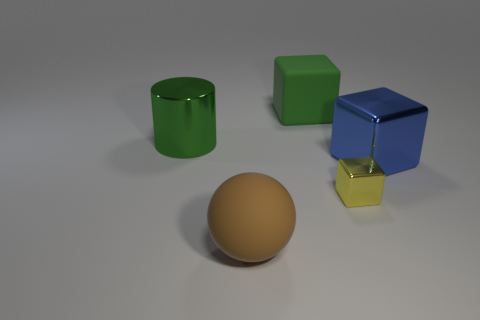Subtract all big blocks. How many blocks are left? 1 Subtract all yellow cubes. How many cubes are left? 2 Add 4 metallic cubes. How many objects exist? 9 Subtract 0 yellow cylinders. How many objects are left? 5 Subtract all blocks. How many objects are left? 2 Subtract 2 cubes. How many cubes are left? 1 Subtract all brown cylinders. Subtract all cyan blocks. How many cylinders are left? 1 Subtract all large brown balls. Subtract all big blue metal blocks. How many objects are left? 3 Add 3 big green metallic objects. How many big green metallic objects are left? 4 Add 5 shiny cubes. How many shiny cubes exist? 7 